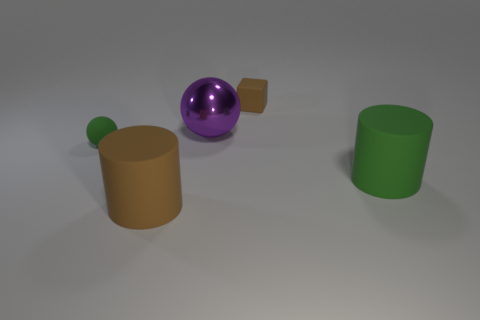Add 3 blue shiny balls. How many objects exist? 8 Subtract all blocks. How many objects are left? 4 Subtract all big green rubber things. Subtract all large rubber cubes. How many objects are left? 4 Add 2 green balls. How many green balls are left? 3 Add 3 tiny brown blocks. How many tiny brown blocks exist? 4 Subtract 0 green blocks. How many objects are left? 5 Subtract all green spheres. Subtract all yellow cubes. How many spheres are left? 1 